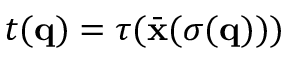Convert formula to latex. <formula><loc_0><loc_0><loc_500><loc_500>t ( { q } ) = \tau ( \bar { x } ( \sigma ( { q } ) ) )</formula> 